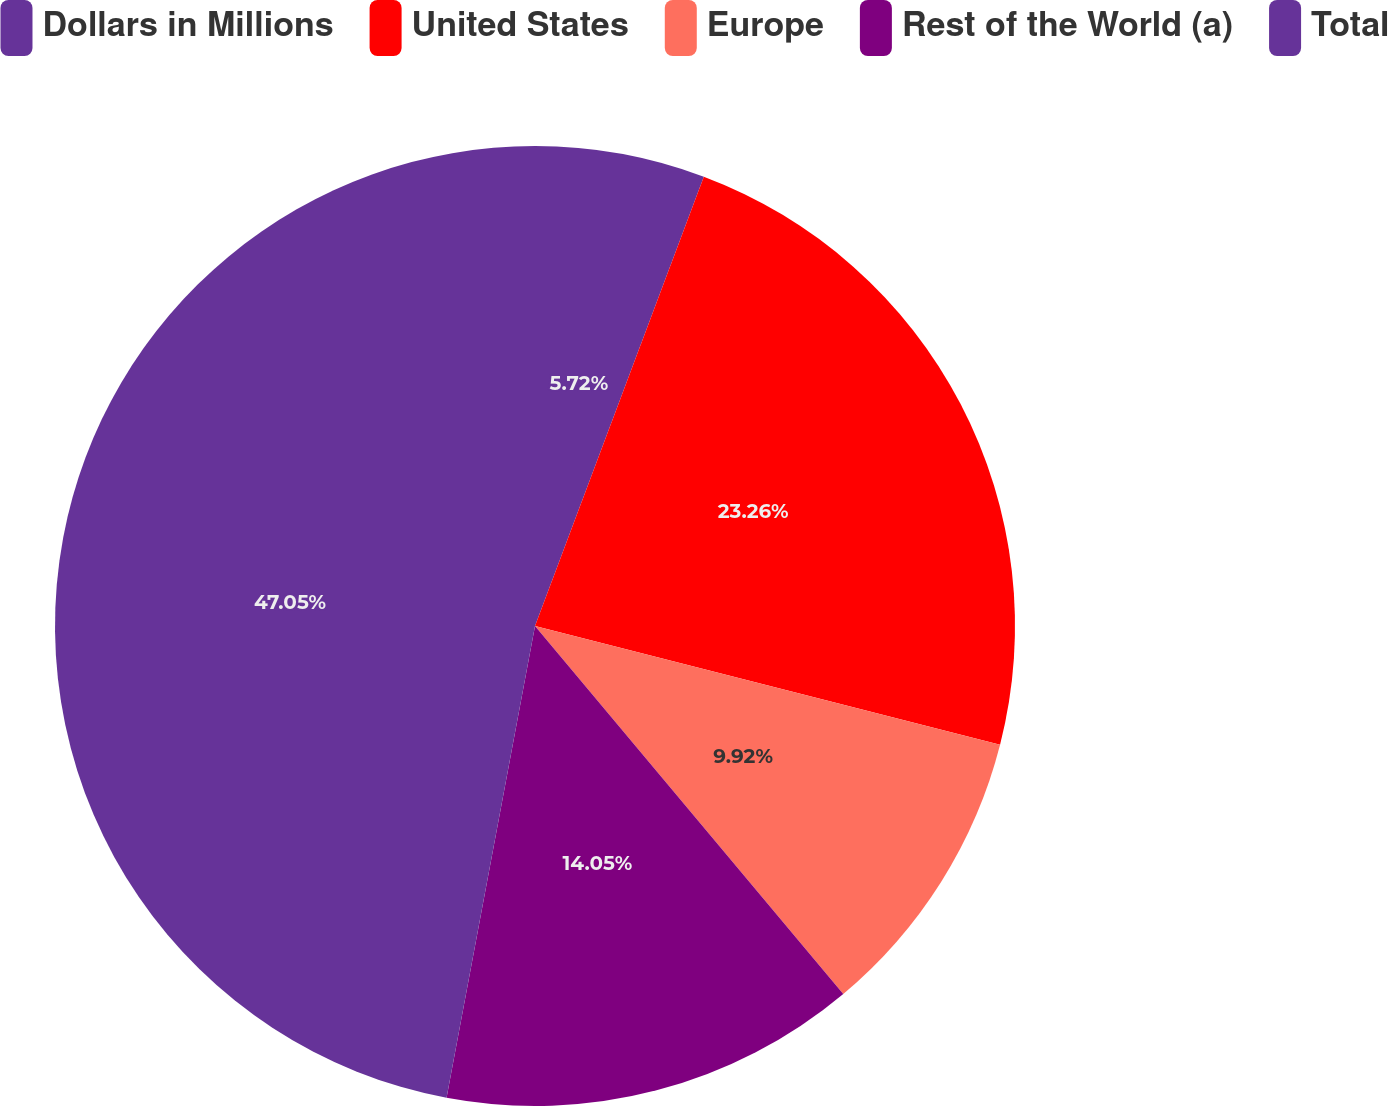Convert chart. <chart><loc_0><loc_0><loc_500><loc_500><pie_chart><fcel>Dollars in Millions<fcel>United States<fcel>Europe<fcel>Rest of the World (a)<fcel>Total<nl><fcel>5.72%<fcel>23.26%<fcel>9.92%<fcel>14.05%<fcel>47.05%<nl></chart> 